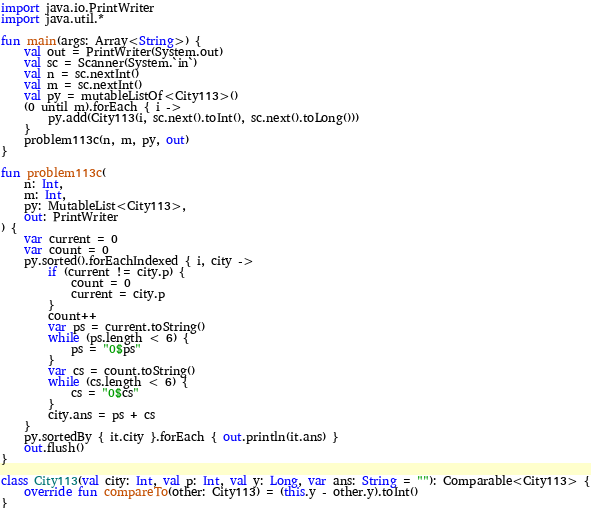Convert code to text. <code><loc_0><loc_0><loc_500><loc_500><_Kotlin_>import java.io.PrintWriter
import java.util.*

fun main(args: Array<String>) {
    val out = PrintWriter(System.out)
    val sc = Scanner(System.`in`)
    val n = sc.nextInt()
    val m = sc.nextInt()
    val py = mutableListOf<City113>()
    (0 until m).forEach { i ->
        py.add(City113(i, sc.next().toInt(), sc.next().toLong()))
    }
    problem113c(n, m, py, out)
}

fun problem113c(
    n: Int,
    m: Int,
    py: MutableList<City113>,
    out: PrintWriter
) {
    var current = 0
    var count = 0
    py.sorted().forEachIndexed { i, city ->
        if (current != city.p) {
            count = 0
            current = city.p
        }
        count++
        var ps = current.toString()
        while (ps.length < 6) {
            ps = "0$ps"
        }
        var cs = count.toString()
        while (cs.length < 6) {
            cs = "0$cs"
        }
        city.ans = ps + cs
    }
    py.sortedBy { it.city }.forEach { out.println(it.ans) }
    out.flush()
}

class City113(val city: Int, val p: Int, val y: Long, var ans: String = ""): Comparable<City113> {
    override fun compareTo(other: City113) = (this.y - other.y).toInt()
}</code> 